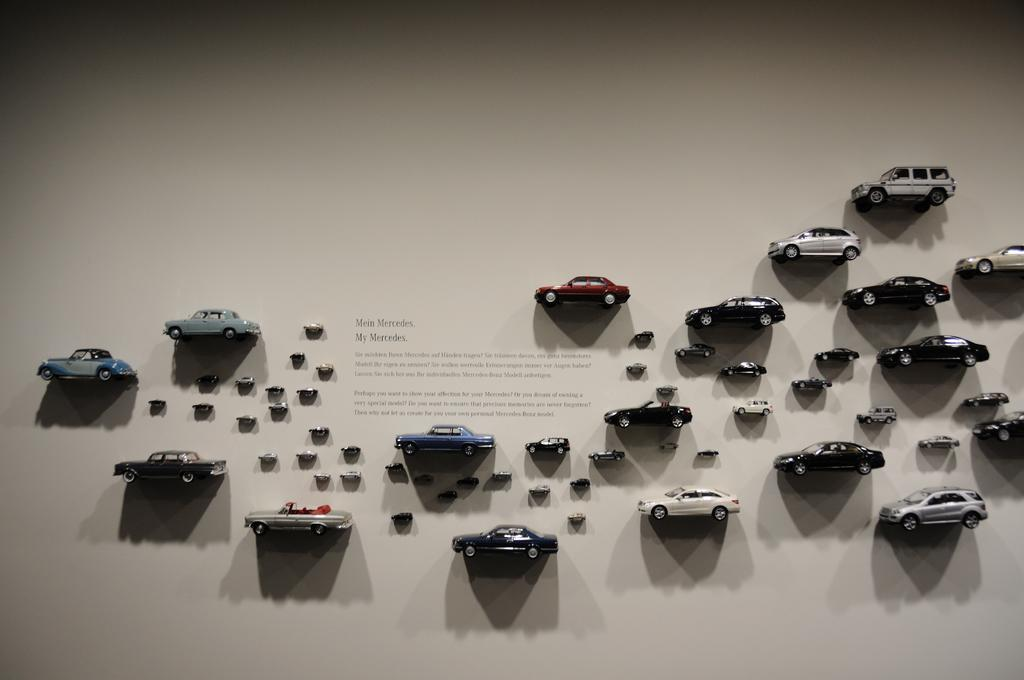What type of toys are visible in the image? There are toy cars in the image. How are the toy cars positioned in the image? The toy cars are stuck to the wall. What can be seen in the center of the image? There is text in the center of the image. What color is the background of the image? The background of the image is white. Can you tell me if the stranger in the image has any desire to own the toy cars? There is no stranger present in the image, so it is not possible to determine their desire for the toy cars. 